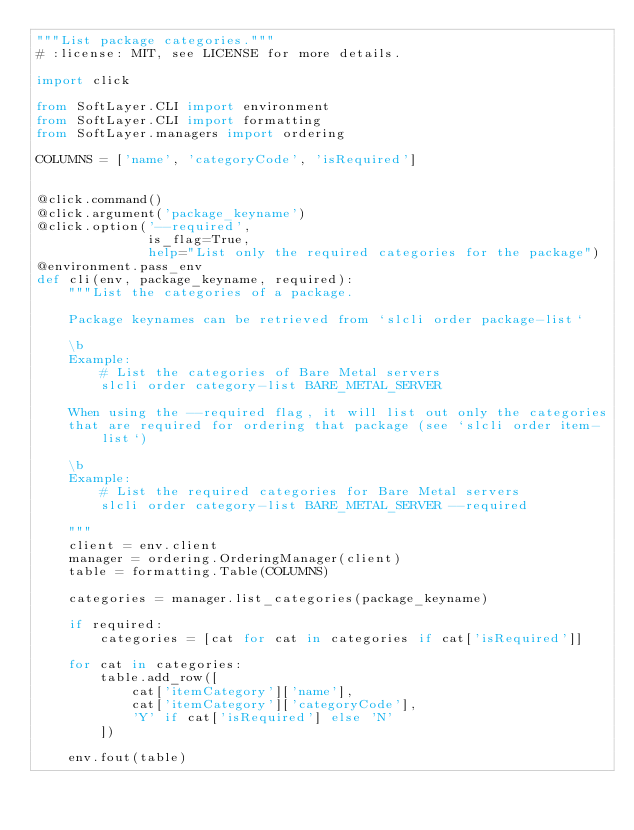<code> <loc_0><loc_0><loc_500><loc_500><_Python_>"""List package categories."""
# :license: MIT, see LICENSE for more details.

import click

from SoftLayer.CLI import environment
from SoftLayer.CLI import formatting
from SoftLayer.managers import ordering

COLUMNS = ['name', 'categoryCode', 'isRequired']


@click.command()
@click.argument('package_keyname')
@click.option('--required',
              is_flag=True,
              help="List only the required categories for the package")
@environment.pass_env
def cli(env, package_keyname, required):
    """List the categories of a package.

    Package keynames can be retrieved from `slcli order package-list`

    \b
    Example:
        # List the categories of Bare Metal servers
        slcli order category-list BARE_METAL_SERVER

    When using the --required flag, it will list out only the categories
    that are required for ordering that package (see `slcli order item-list`)

    \b
    Example:
        # List the required categories for Bare Metal servers
        slcli order category-list BARE_METAL_SERVER --required

    """
    client = env.client
    manager = ordering.OrderingManager(client)
    table = formatting.Table(COLUMNS)

    categories = manager.list_categories(package_keyname)

    if required:
        categories = [cat for cat in categories if cat['isRequired']]

    for cat in categories:
        table.add_row([
            cat['itemCategory']['name'],
            cat['itemCategory']['categoryCode'],
            'Y' if cat['isRequired'] else 'N'
        ])

    env.fout(table)
</code> 